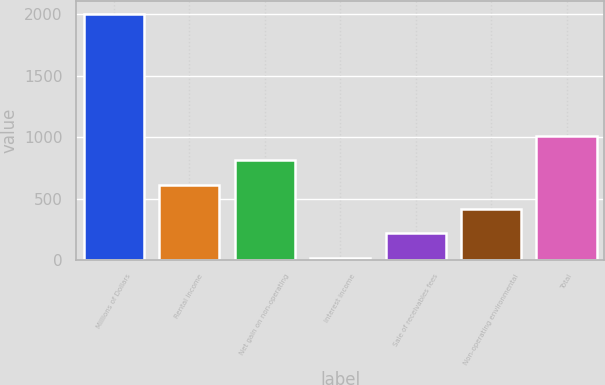Convert chart. <chart><loc_0><loc_0><loc_500><loc_500><bar_chart><fcel>Millions of Dollars<fcel>Rental income<fcel>Net gain on non-operating<fcel>Interest income<fcel>Sale of receivables fees<fcel>Non-operating environmental<fcel>Total<nl><fcel>2005<fcel>613.4<fcel>812.2<fcel>17<fcel>215.8<fcel>414.6<fcel>1011<nl></chart> 